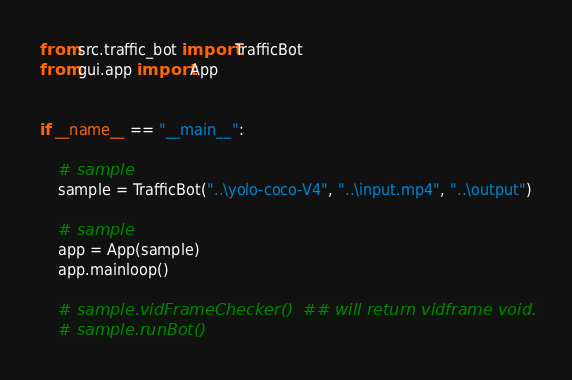<code> <loc_0><loc_0><loc_500><loc_500><_Python_>from src.traffic_bot import TrafficBot
from gui.app import App


if __name__ == "__main__":

    # sample
    sample = TrafficBot("..\yolo-coco-V4", "..\input.mp4", "..\output")

    # sample
    app = App(sample)
    app.mainloop()

    # sample.vidFrameChecker()  ## will return vidframe void.
    # sample.runBot()
</code> 